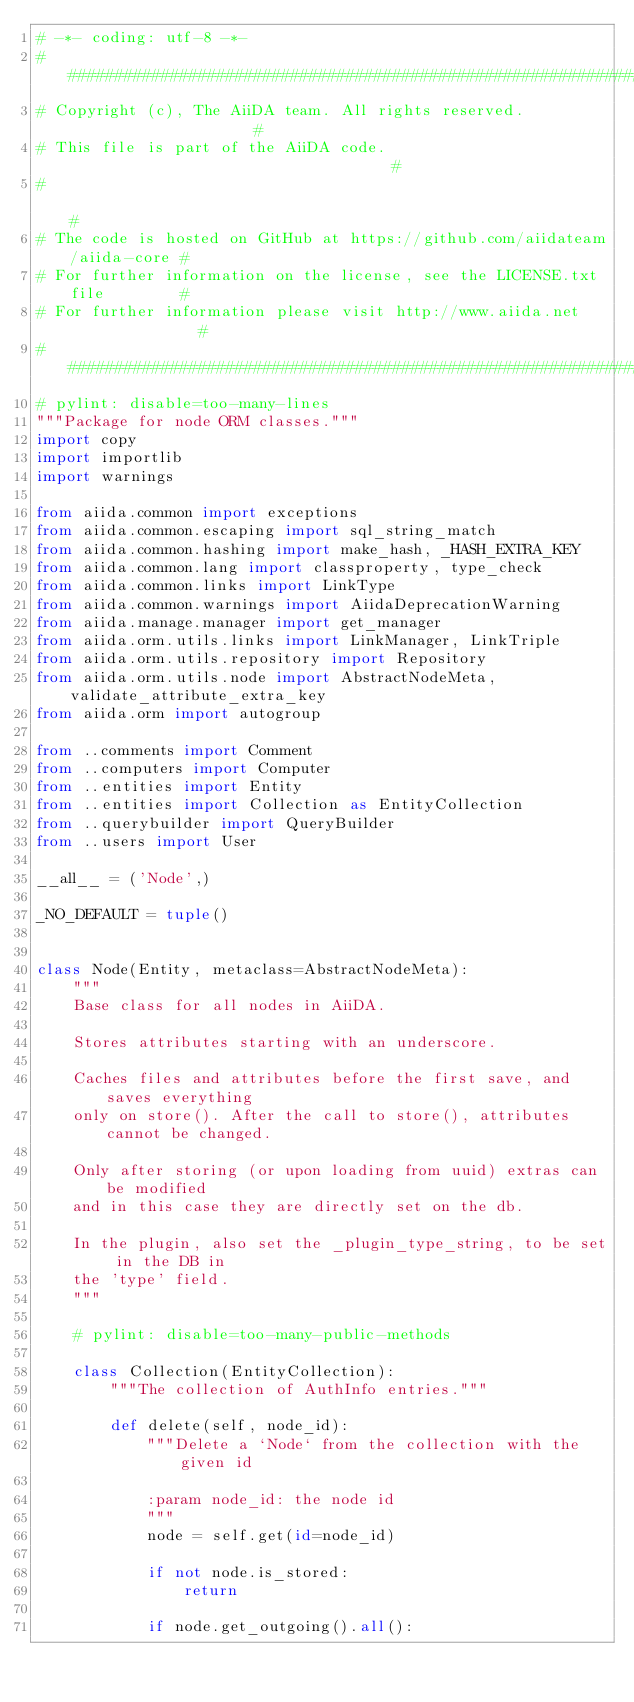<code> <loc_0><loc_0><loc_500><loc_500><_Python_># -*- coding: utf-8 -*-
###########################################################################
# Copyright (c), The AiiDA team. All rights reserved.                     #
# This file is part of the AiiDA code.                                    #
#                                                                         #
# The code is hosted on GitHub at https://github.com/aiidateam/aiida-core #
# For further information on the license, see the LICENSE.txt file        #
# For further information please visit http://www.aiida.net               #
###########################################################################
# pylint: disable=too-many-lines
"""Package for node ORM classes."""
import copy
import importlib
import warnings

from aiida.common import exceptions
from aiida.common.escaping import sql_string_match
from aiida.common.hashing import make_hash, _HASH_EXTRA_KEY
from aiida.common.lang import classproperty, type_check
from aiida.common.links import LinkType
from aiida.common.warnings import AiidaDeprecationWarning
from aiida.manage.manager import get_manager
from aiida.orm.utils.links import LinkManager, LinkTriple
from aiida.orm.utils.repository import Repository
from aiida.orm.utils.node import AbstractNodeMeta, validate_attribute_extra_key
from aiida.orm import autogroup

from ..comments import Comment
from ..computers import Computer
from ..entities import Entity
from ..entities import Collection as EntityCollection
from ..querybuilder import QueryBuilder
from ..users import User

__all__ = ('Node',)

_NO_DEFAULT = tuple()


class Node(Entity, metaclass=AbstractNodeMeta):
    """
    Base class for all nodes in AiiDA.

    Stores attributes starting with an underscore.

    Caches files and attributes before the first save, and saves everything
    only on store(). After the call to store(), attributes cannot be changed.

    Only after storing (or upon loading from uuid) extras can be modified
    and in this case they are directly set on the db.

    In the plugin, also set the _plugin_type_string, to be set in the DB in
    the 'type' field.
    """

    # pylint: disable=too-many-public-methods

    class Collection(EntityCollection):
        """The collection of AuthInfo entries."""

        def delete(self, node_id):
            """Delete a `Node` from the collection with the given id

            :param node_id: the node id
            """
            node = self.get(id=node_id)

            if not node.is_stored:
                return

            if node.get_outgoing().all():</code> 